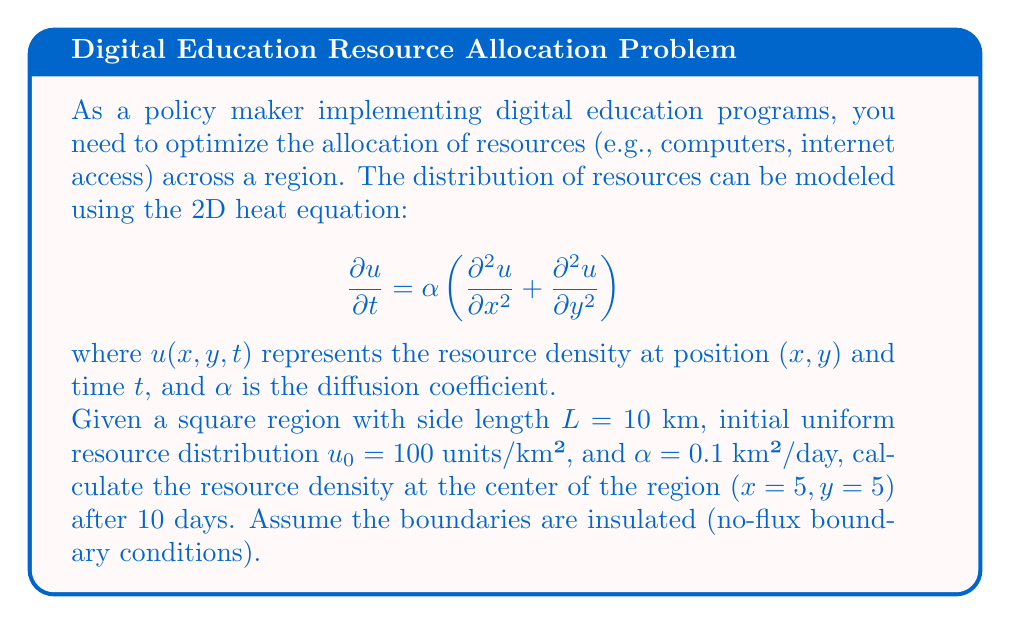What is the answer to this math problem? To solve this problem, we need to use the solution of the 2D heat equation with insulated boundaries. The general solution for this scenario is:

$$u(x,y,t) = u_0 + \sum_{m=1}^{\infty}\sum_{n=1}^{\infty} A_{mn} \cos\left(\frac{m\pi x}{L}\right)\cos\left(\frac{n\pi y}{L}\right)e^{-\alpha(m^2+n^2)\pi^2t/L^2}$$

where $A_{mn}$ are the Fourier coefficients determined by the initial conditions.

In our case, the initial condition is uniform, so all $A_{mn} = 0$ except for $A_{00} = u_0$. This simplifies our solution to:

$$u(x,y,t) = u_0 = 100$$

This means that the resource density remains constant over time and space due to the uniform initial distribution and insulated boundaries.

To verify, let's check the values:

1. $u_0 = 100$ units/km²
2. $L = 10$ km
3. $\alpha = 0.1$ km²/day
4. $t = 10$ days
5. $(x,y) = (5,5)$ km

Substituting these values into our simplified solution:

$$u(5,5,10) = 100$$

Therefore, the resource density at the center of the region after 10 days remains 100 units/km².
Answer: 100 units/km² 